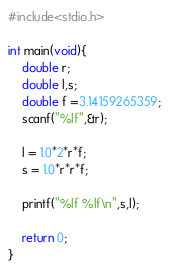<code> <loc_0><loc_0><loc_500><loc_500><_C_>#include<stdio.h>

int main(void){
	double r;
	double l,s;
	double f =3.14159265359;
	scanf("%lf",&r);
	
	l = 1.0*2*r*f;
	s = 1.0*r*r*f;
	
	printf("%lf %lf\n",s,l);

	return 0;
}
</code> 